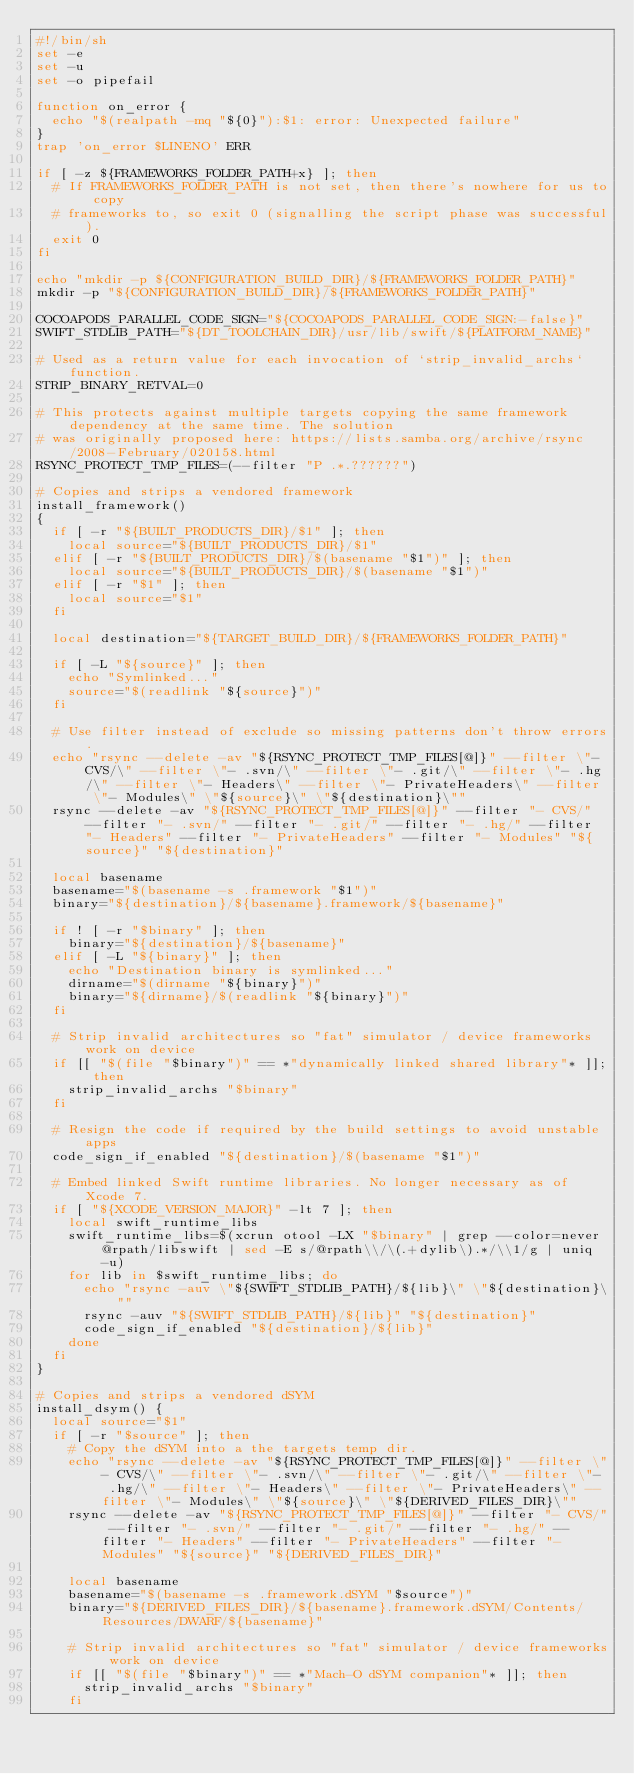<code> <loc_0><loc_0><loc_500><loc_500><_Bash_>#!/bin/sh
set -e
set -u
set -o pipefail

function on_error {
  echo "$(realpath -mq "${0}"):$1: error: Unexpected failure"
}
trap 'on_error $LINENO' ERR

if [ -z ${FRAMEWORKS_FOLDER_PATH+x} ]; then
  # If FRAMEWORKS_FOLDER_PATH is not set, then there's nowhere for us to copy
  # frameworks to, so exit 0 (signalling the script phase was successful).
  exit 0
fi

echo "mkdir -p ${CONFIGURATION_BUILD_DIR}/${FRAMEWORKS_FOLDER_PATH}"
mkdir -p "${CONFIGURATION_BUILD_DIR}/${FRAMEWORKS_FOLDER_PATH}"

COCOAPODS_PARALLEL_CODE_SIGN="${COCOAPODS_PARALLEL_CODE_SIGN:-false}"
SWIFT_STDLIB_PATH="${DT_TOOLCHAIN_DIR}/usr/lib/swift/${PLATFORM_NAME}"

# Used as a return value for each invocation of `strip_invalid_archs` function.
STRIP_BINARY_RETVAL=0

# This protects against multiple targets copying the same framework dependency at the same time. The solution
# was originally proposed here: https://lists.samba.org/archive/rsync/2008-February/020158.html
RSYNC_PROTECT_TMP_FILES=(--filter "P .*.??????")

# Copies and strips a vendored framework
install_framework()
{
  if [ -r "${BUILT_PRODUCTS_DIR}/$1" ]; then
    local source="${BUILT_PRODUCTS_DIR}/$1"
  elif [ -r "${BUILT_PRODUCTS_DIR}/$(basename "$1")" ]; then
    local source="${BUILT_PRODUCTS_DIR}/$(basename "$1")"
  elif [ -r "$1" ]; then
    local source="$1"
  fi

  local destination="${TARGET_BUILD_DIR}/${FRAMEWORKS_FOLDER_PATH}"

  if [ -L "${source}" ]; then
    echo "Symlinked..."
    source="$(readlink "${source}")"
  fi

  # Use filter instead of exclude so missing patterns don't throw errors.
  echo "rsync --delete -av "${RSYNC_PROTECT_TMP_FILES[@]}" --filter \"- CVS/\" --filter \"- .svn/\" --filter \"- .git/\" --filter \"- .hg/\" --filter \"- Headers\" --filter \"- PrivateHeaders\" --filter \"- Modules\" \"${source}\" \"${destination}\""
  rsync --delete -av "${RSYNC_PROTECT_TMP_FILES[@]}" --filter "- CVS/" --filter "- .svn/" --filter "- .git/" --filter "- .hg/" --filter "- Headers" --filter "- PrivateHeaders" --filter "- Modules" "${source}" "${destination}"

  local basename
  basename="$(basename -s .framework "$1")"
  binary="${destination}/${basename}.framework/${basename}"

  if ! [ -r "$binary" ]; then
    binary="${destination}/${basename}"
  elif [ -L "${binary}" ]; then
    echo "Destination binary is symlinked..."
    dirname="$(dirname "${binary}")"
    binary="${dirname}/$(readlink "${binary}")"
  fi

  # Strip invalid architectures so "fat" simulator / device frameworks work on device
  if [[ "$(file "$binary")" == *"dynamically linked shared library"* ]]; then
    strip_invalid_archs "$binary"
  fi

  # Resign the code if required by the build settings to avoid unstable apps
  code_sign_if_enabled "${destination}/$(basename "$1")"

  # Embed linked Swift runtime libraries. No longer necessary as of Xcode 7.
  if [ "${XCODE_VERSION_MAJOR}" -lt 7 ]; then
    local swift_runtime_libs
    swift_runtime_libs=$(xcrun otool -LX "$binary" | grep --color=never @rpath/libswift | sed -E s/@rpath\\/\(.+dylib\).*/\\1/g | uniq -u)
    for lib in $swift_runtime_libs; do
      echo "rsync -auv \"${SWIFT_STDLIB_PATH}/${lib}\" \"${destination}\""
      rsync -auv "${SWIFT_STDLIB_PATH}/${lib}" "${destination}"
      code_sign_if_enabled "${destination}/${lib}"
    done
  fi
}

# Copies and strips a vendored dSYM
install_dsym() {
  local source="$1"
  if [ -r "$source" ]; then
    # Copy the dSYM into a the targets temp dir.
    echo "rsync --delete -av "${RSYNC_PROTECT_TMP_FILES[@]}" --filter \"- CVS/\" --filter \"- .svn/\" --filter \"- .git/\" --filter \"- .hg/\" --filter \"- Headers\" --filter \"- PrivateHeaders\" --filter \"- Modules\" \"${source}\" \"${DERIVED_FILES_DIR}\""
    rsync --delete -av "${RSYNC_PROTECT_TMP_FILES[@]}" --filter "- CVS/" --filter "- .svn/" --filter "- .git/" --filter "- .hg/" --filter "- Headers" --filter "- PrivateHeaders" --filter "- Modules" "${source}" "${DERIVED_FILES_DIR}"

    local basename
    basename="$(basename -s .framework.dSYM "$source")"
    binary="${DERIVED_FILES_DIR}/${basename}.framework.dSYM/Contents/Resources/DWARF/${basename}"

    # Strip invalid architectures so "fat" simulator / device frameworks work on device
    if [[ "$(file "$binary")" == *"Mach-O dSYM companion"* ]]; then
      strip_invalid_archs "$binary"
    fi
</code> 